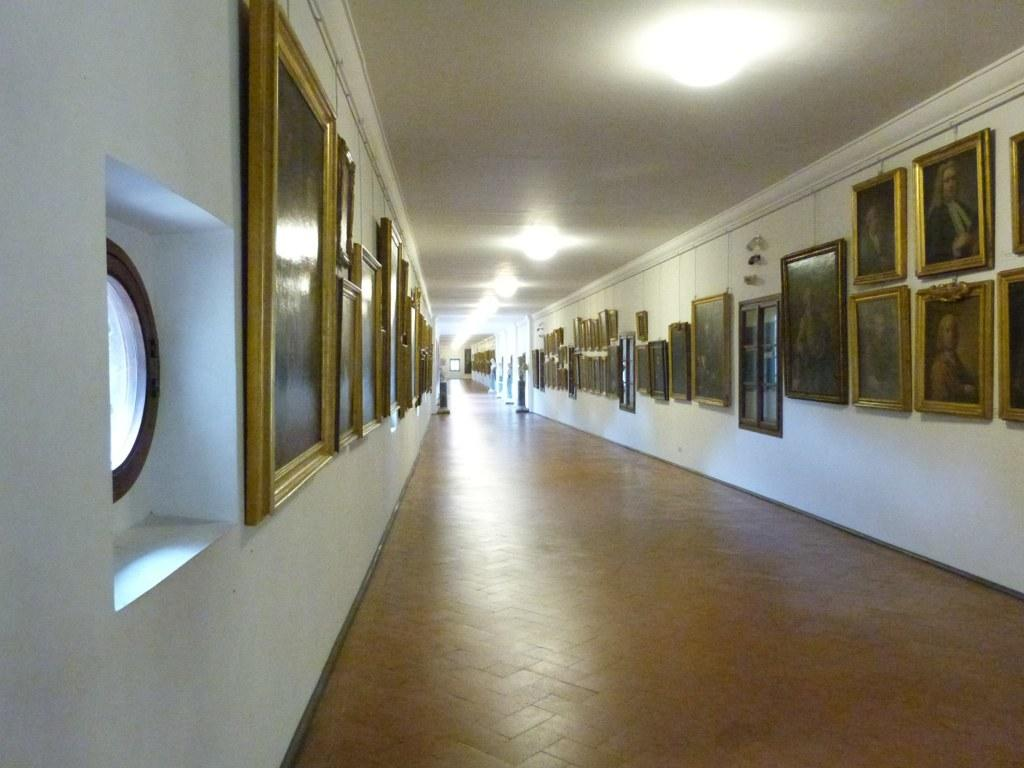What can be seen hanging on the wall in the image? There are frames on the wall in the image. What type of illumination is present at the top of the image? There are lights at the top of the image. What is the surface that people or objects are standing on in the image? There is a floor at the bottom of the image. What type of infrastructure is visible at the top of the image? There are pipes at the top of the image. Can you tell me how many brothers are swimming in the image? There are no brothers or swimming activity present in the image. What type of magic is being performed in the image? There is no magic or performance present in the image. 